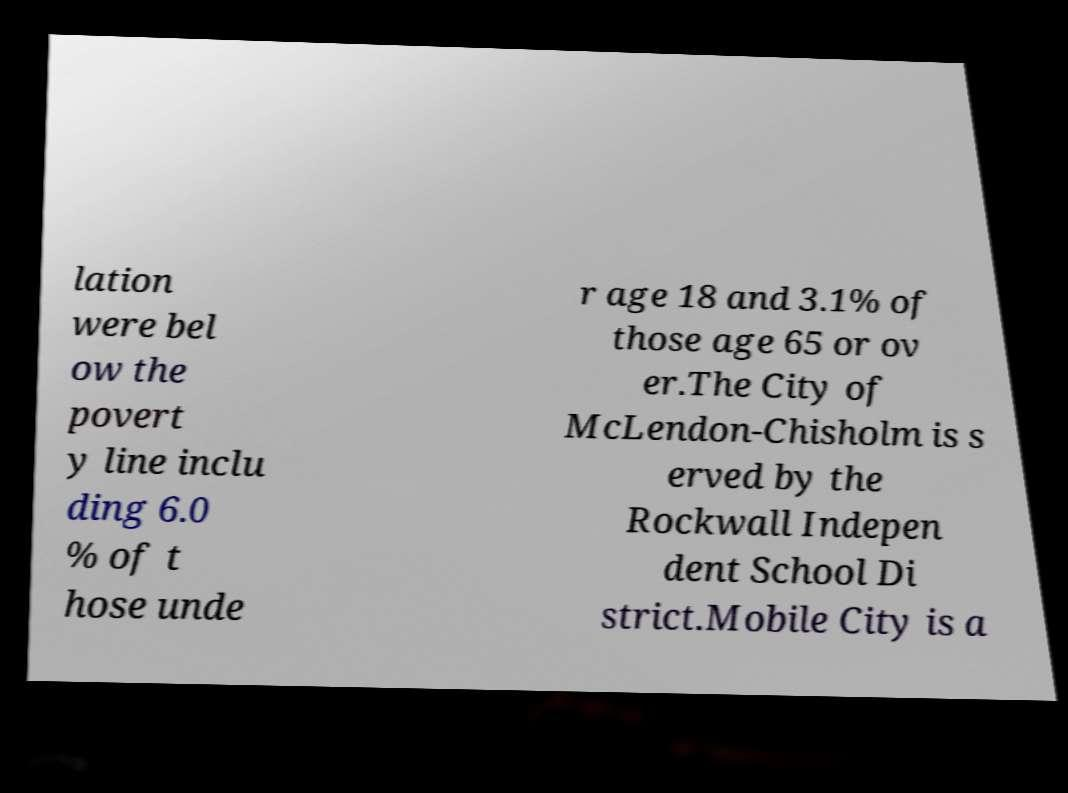Please read and relay the text visible in this image. What does it say? lation were bel ow the povert y line inclu ding 6.0 % of t hose unde r age 18 and 3.1% of those age 65 or ov er.The City of McLendon-Chisholm is s erved by the Rockwall Indepen dent School Di strict.Mobile City is a 